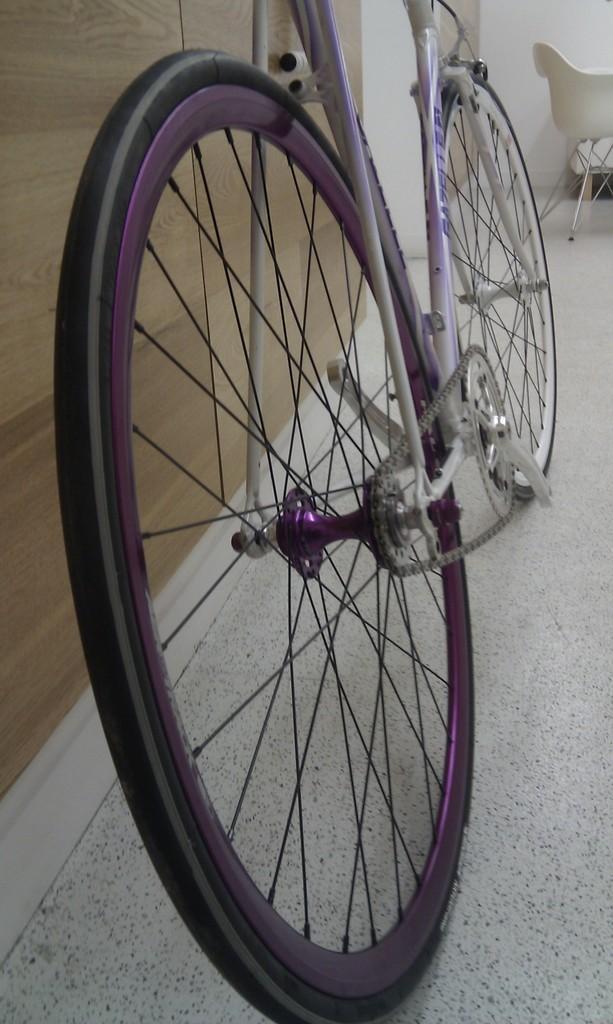Can you describe this image briefly? In the image we can see there is a bicycle which is kept attached to the wall which is made up of wood and the bicycle is in white and purple colour. 